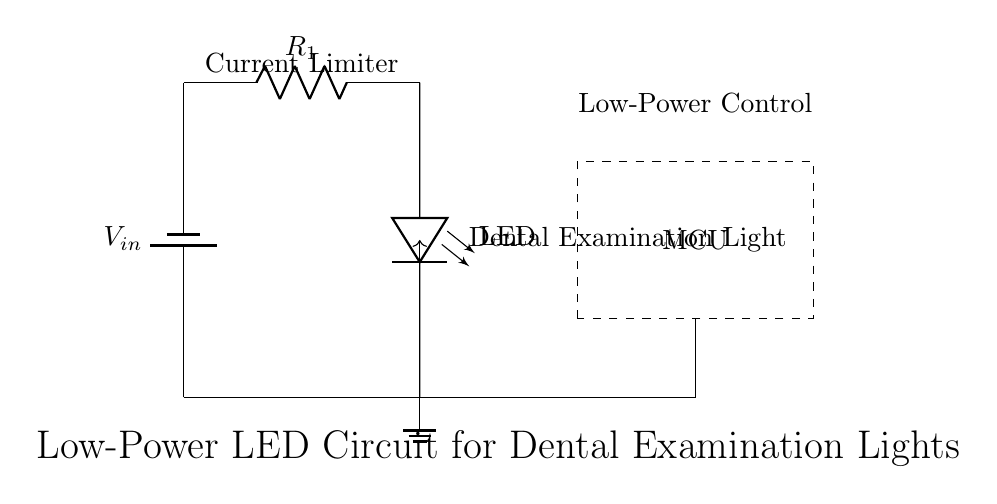What type of light does this circuit produce? The circuit produces LED light, as indicated by the LED component labeled in the diagram.
Answer: LED light What is the purpose of the resistor in this circuit? The resistor is a current limiter, which is meant to restrict the amount of current flowing through the LED to prevent it from burning out.
Answer: Current limiter How is the LED controlled in this circuit? The LED is controlled by a microcontroller through a PWM control line, which adjusts its brightness by varying the duty cycle.
Answer: PWM control What current component is essential for the LED operation? The current limiting resistor is essential for the LED operation to ensure it receives the appropriate current for safe illumination.
Answer: Current limiting resistor What is the function of the microcontroller in this circuit? The microcontroller's function is to manage and control the operation of the LED, particularly through adjusting the brightness via PWM signals.
Answer: Control the LED What is the ground reference used in this circuit? The ground reference is provided at the bottom terminal of the circuit where it connects to ground, creating a common reference point for all voltages in the circuit.
Answer: Ground What is the significance of including the battery in this circuit? The battery provides the necessary input voltage to power the circuit, and it's crucial for the operation of the LED and microcontroller.
Answer: Power supply 